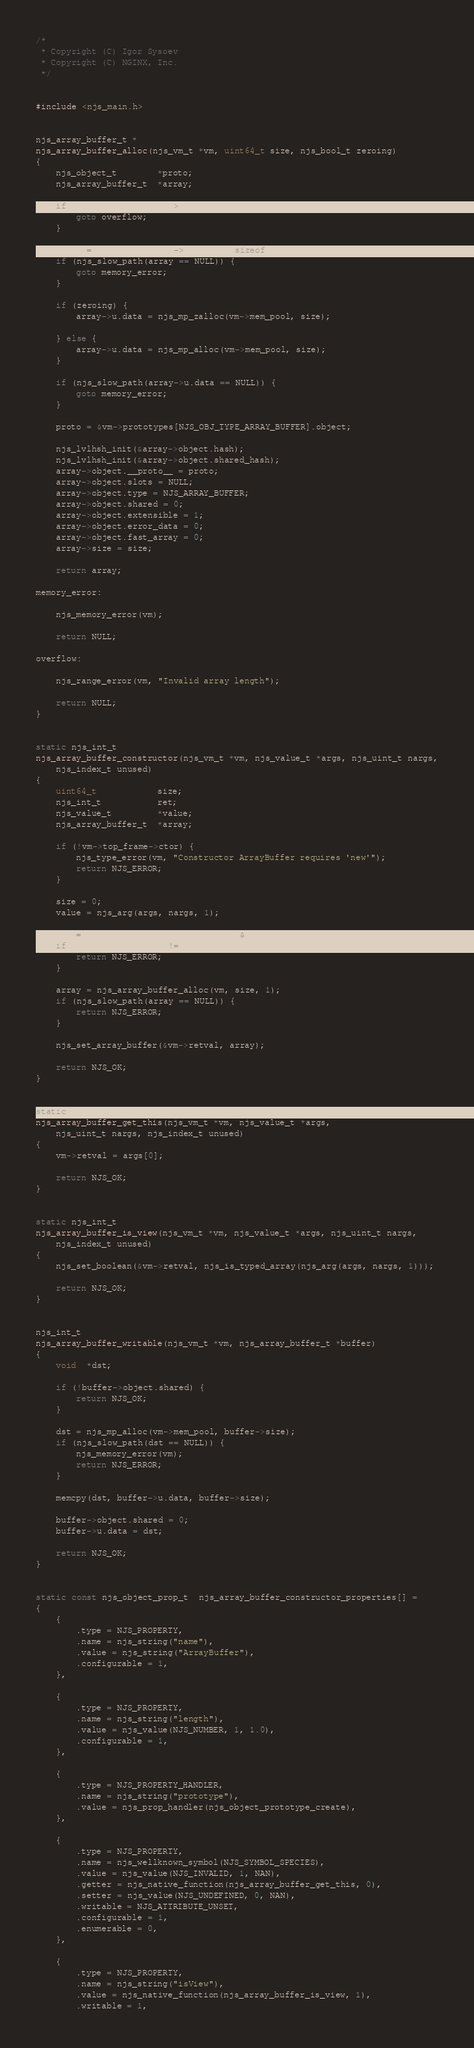Convert code to text. <code><loc_0><loc_0><loc_500><loc_500><_C_>/*
 * Copyright (C) Igor Sysoev
 * Copyright (C) NGINX, Inc.
 */


#include <njs_main.h>


njs_array_buffer_t *
njs_array_buffer_alloc(njs_vm_t *vm, uint64_t size, njs_bool_t zeroing)
{
    njs_object_t        *proto;
    njs_array_buffer_t  *array;

    if (njs_slow_path(size > UINT32_MAX)) {
        goto overflow;
    }

    array = njs_mp_alloc(vm->mem_pool, sizeof(njs_array_buffer_t));
    if (njs_slow_path(array == NULL)) {
        goto memory_error;
    }

    if (zeroing) {
        array->u.data = njs_mp_zalloc(vm->mem_pool, size);

    } else {
        array->u.data = njs_mp_alloc(vm->mem_pool, size);
    }

    if (njs_slow_path(array->u.data == NULL)) {
        goto memory_error;
    }

    proto = &vm->prototypes[NJS_OBJ_TYPE_ARRAY_BUFFER].object;

    njs_lvlhsh_init(&array->object.hash);
    njs_lvlhsh_init(&array->object.shared_hash);
    array->object.__proto__ = proto;
    array->object.slots = NULL;
    array->object.type = NJS_ARRAY_BUFFER;
    array->object.shared = 0;
    array->object.extensible = 1;
    array->object.error_data = 0;
    array->object.fast_array = 0;
    array->size = size;

    return array;

memory_error:

    njs_memory_error(vm);

    return NULL;

overflow:

    njs_range_error(vm, "Invalid array length");

    return NULL;
}


static njs_int_t
njs_array_buffer_constructor(njs_vm_t *vm, njs_value_t *args, njs_uint_t nargs,
    njs_index_t unused)
{
    uint64_t            size;
    njs_int_t           ret;
    njs_value_t         *value;
    njs_array_buffer_t  *array;

    if (!vm->top_frame->ctor) {
        njs_type_error(vm, "Constructor ArrayBuffer requires 'new'");
        return NJS_ERROR;
    }

    size = 0;
    value = njs_arg(args, nargs, 1);

    ret = njs_value_to_index(vm, value, &size);
    if (njs_slow_path(ret != NJS_OK)) {
        return NJS_ERROR;
    }

    array = njs_array_buffer_alloc(vm, size, 1);
    if (njs_slow_path(array == NULL)) {
        return NJS_ERROR;
    }

    njs_set_array_buffer(&vm->retval, array);

    return NJS_OK;
}


static njs_int_t
njs_array_buffer_get_this(njs_vm_t *vm, njs_value_t *args,
    njs_uint_t nargs, njs_index_t unused)
{
    vm->retval = args[0];

    return NJS_OK;
}


static njs_int_t
njs_array_buffer_is_view(njs_vm_t *vm, njs_value_t *args, njs_uint_t nargs,
    njs_index_t unused)
{
    njs_set_boolean(&vm->retval, njs_is_typed_array(njs_arg(args, nargs, 1)));

    return NJS_OK;
}


njs_int_t
njs_array_buffer_writable(njs_vm_t *vm, njs_array_buffer_t *buffer)
{
    void  *dst;

    if (!buffer->object.shared) {
        return NJS_OK;
    }

    dst = njs_mp_alloc(vm->mem_pool, buffer->size);
    if (njs_slow_path(dst == NULL)) {
        njs_memory_error(vm);
        return NJS_ERROR;
    }

    memcpy(dst, buffer->u.data, buffer->size);

    buffer->object.shared = 0;
    buffer->u.data = dst;

    return NJS_OK;
}


static const njs_object_prop_t  njs_array_buffer_constructor_properties[] =
{
    {
        .type = NJS_PROPERTY,
        .name = njs_string("name"),
        .value = njs_string("ArrayBuffer"),
        .configurable = 1,
    },

    {
        .type = NJS_PROPERTY,
        .name = njs_string("length"),
        .value = njs_value(NJS_NUMBER, 1, 1.0),
        .configurable = 1,
    },

    {
        .type = NJS_PROPERTY_HANDLER,
        .name = njs_string("prototype"),
        .value = njs_prop_handler(njs_object_prototype_create),
    },

    {
        .type = NJS_PROPERTY,
        .name = njs_wellknown_symbol(NJS_SYMBOL_SPECIES),
        .value = njs_value(NJS_INVALID, 1, NAN),
        .getter = njs_native_function(njs_array_buffer_get_this, 0),
        .setter = njs_value(NJS_UNDEFINED, 0, NAN),
        .writable = NJS_ATTRIBUTE_UNSET,
        .configurable = 1,
        .enumerable = 0,
    },

    {
        .type = NJS_PROPERTY,
        .name = njs_string("isView"),
        .value = njs_native_function(njs_array_buffer_is_view, 1),
        .writable = 1,</code> 